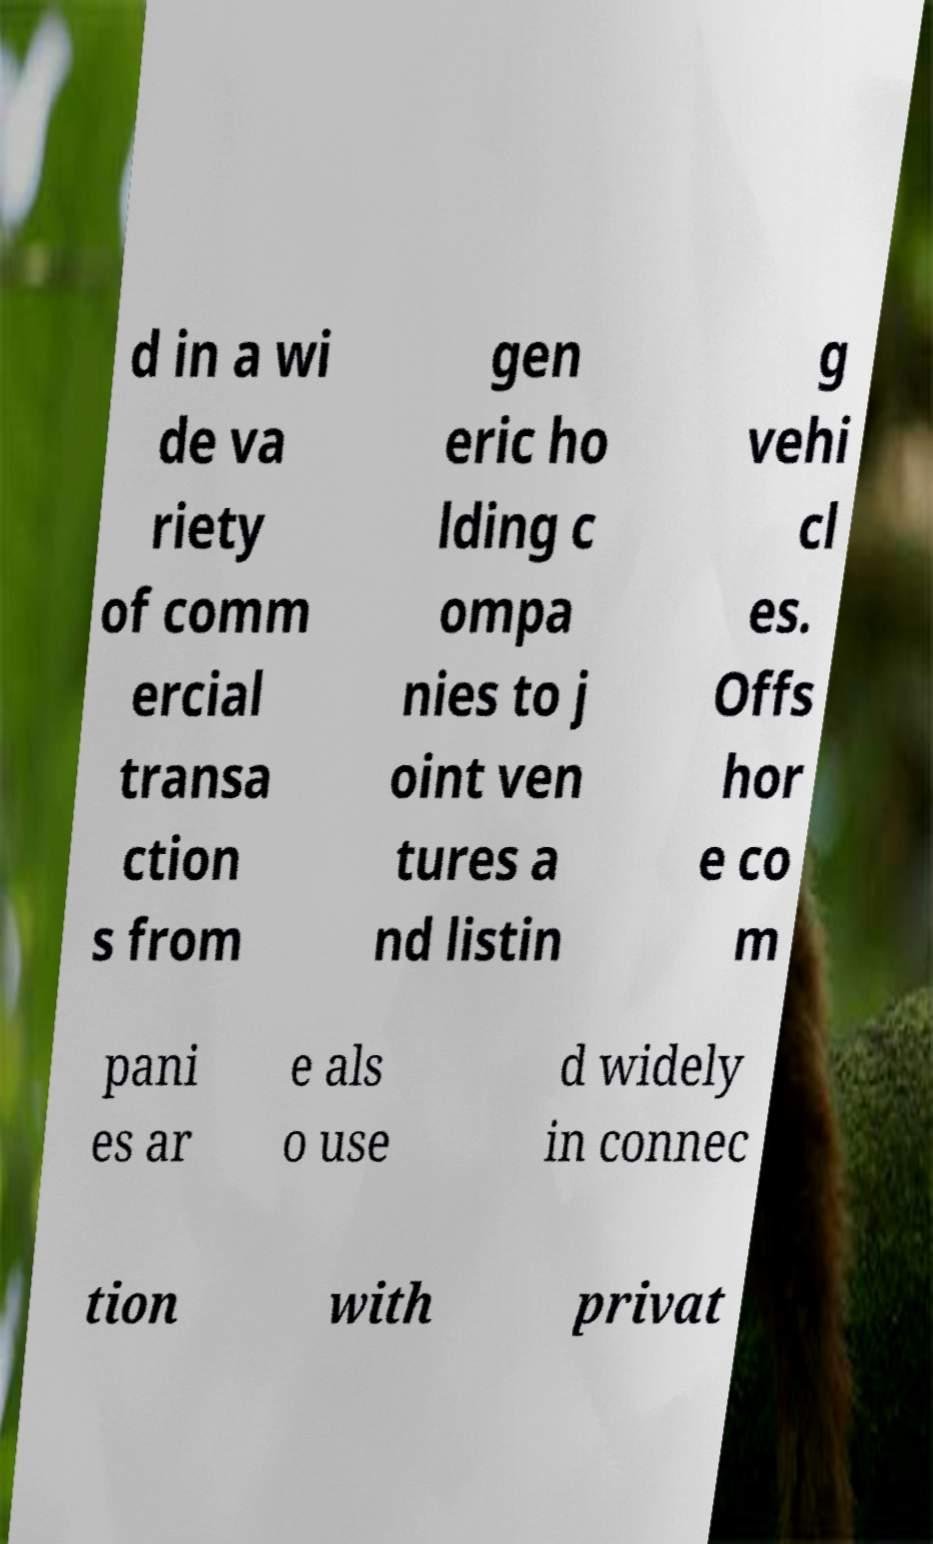Could you extract and type out the text from this image? d in a wi de va riety of comm ercial transa ction s from gen eric ho lding c ompa nies to j oint ven tures a nd listin g vehi cl es. Offs hor e co m pani es ar e als o use d widely in connec tion with privat 